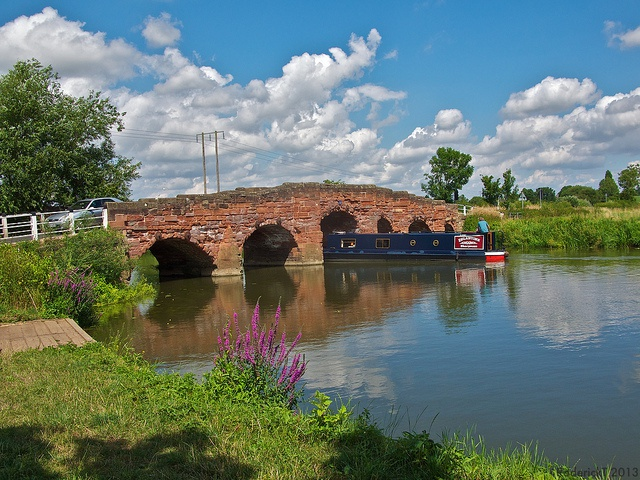Describe the objects in this image and their specific colors. I can see boat in gray, black, navy, blue, and maroon tones, car in gray, black, darkgray, and darkgreen tones, and people in gray, lightblue, blue, and olive tones in this image. 